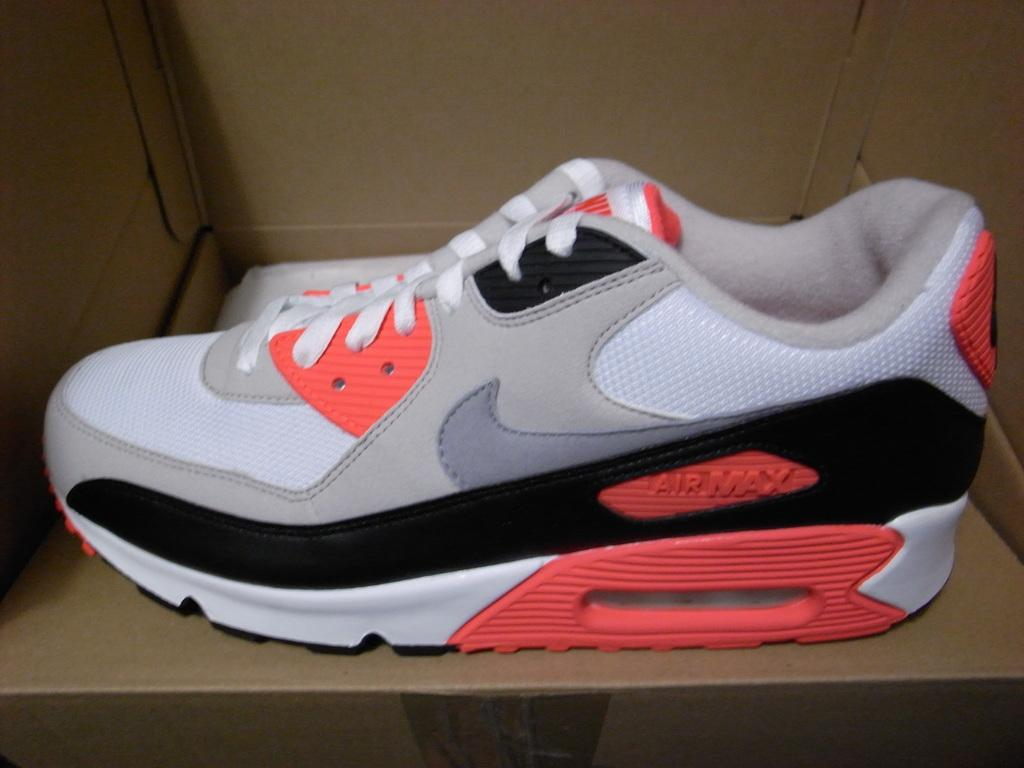What object is inside the box in the image? There is a shoe in the image. What is the condition of the shoe in the image? The shoe is inside a box. What colors can be seen on the shoe in the image? The shoe has orange, black, grey, and white colors. What type of stocking is covering the volcano in the image? There is no stocking or volcano present in the image; it features a shoe inside a box with specific colors. 